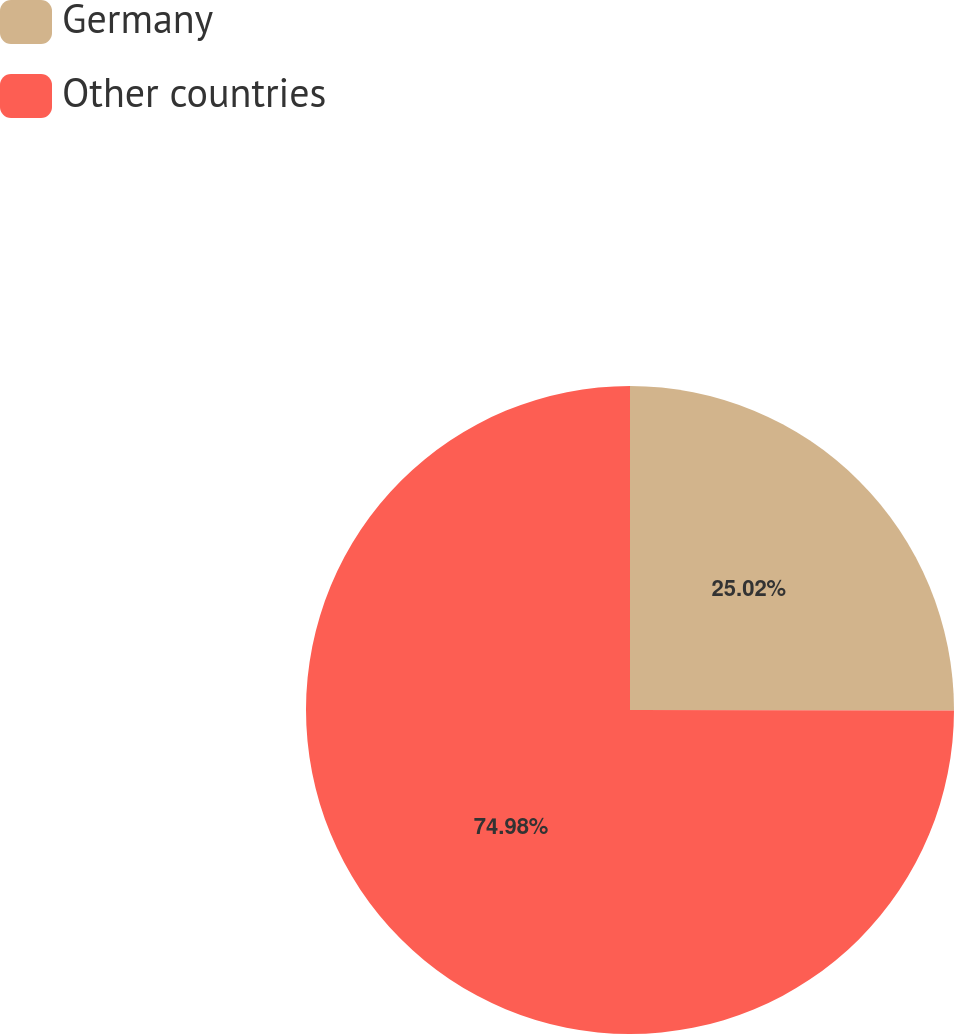Convert chart to OTSL. <chart><loc_0><loc_0><loc_500><loc_500><pie_chart><fcel>Germany<fcel>Other countries<nl><fcel>25.02%<fcel>74.98%<nl></chart> 